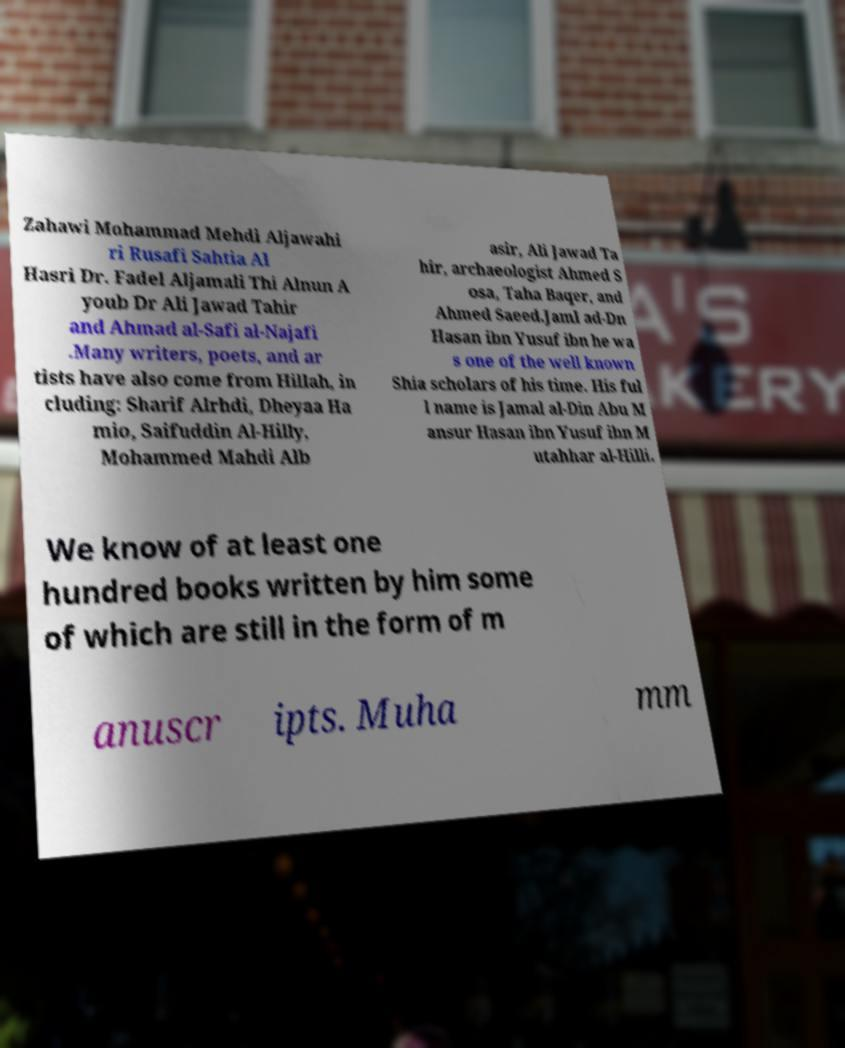For documentation purposes, I need the text within this image transcribed. Could you provide that? Zahawi Mohammad Mehdi Aljawahi ri Rusafi Sahtia Al Hasri Dr. Fadel Aljamali Thi Alnun A youb Dr Ali Jawad Tahir and Ahmad al-Safi al-Najafi .Many writers, poets, and ar tists have also come from Hillah, in cluding: Sharif Alrhdi, Dheyaa Ha mio, Saifuddin Al-Hilly, Mohammed Mahdi Alb asir, Ali Jawad Ta hir, archaeologist Ahmed S osa, Taha Baqer, and Ahmed Saeed.Jaml ad-Dn Hasan ibn Yusuf ibn he wa s one of the well known Shia scholars of his time. His ful l name is Jamal al-Din Abu M ansur Hasan ibn Yusuf ibn M utahhar al-Hilli. We know of at least one hundred books written by him some of which are still in the form of m anuscr ipts. Muha mm 